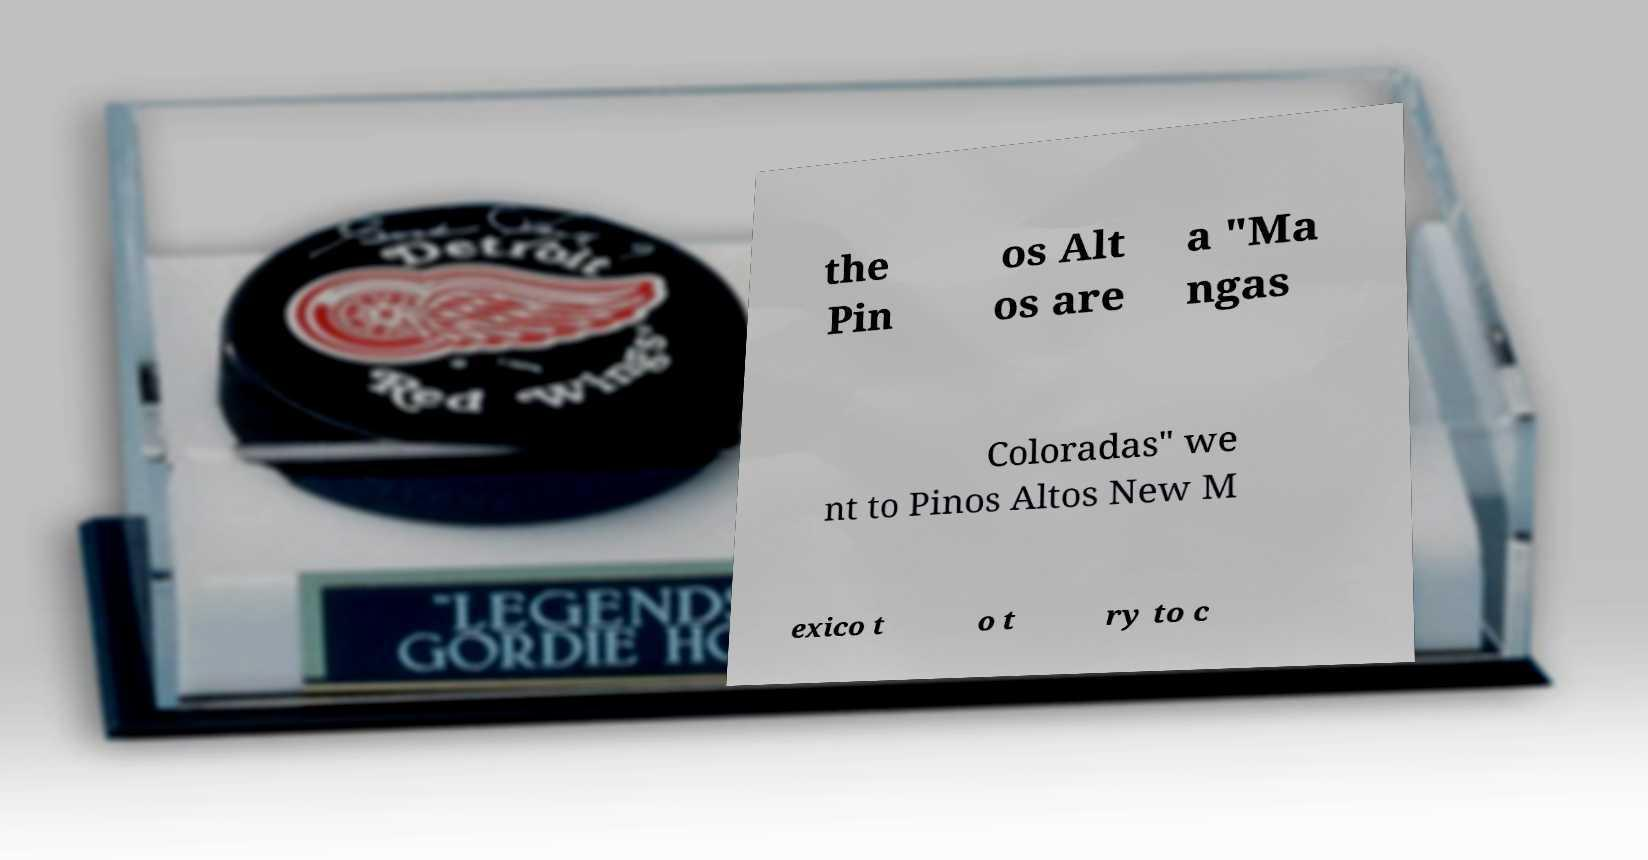Please identify and transcribe the text found in this image. the Pin os Alt os are a "Ma ngas Coloradas" we nt to Pinos Altos New M exico t o t ry to c 